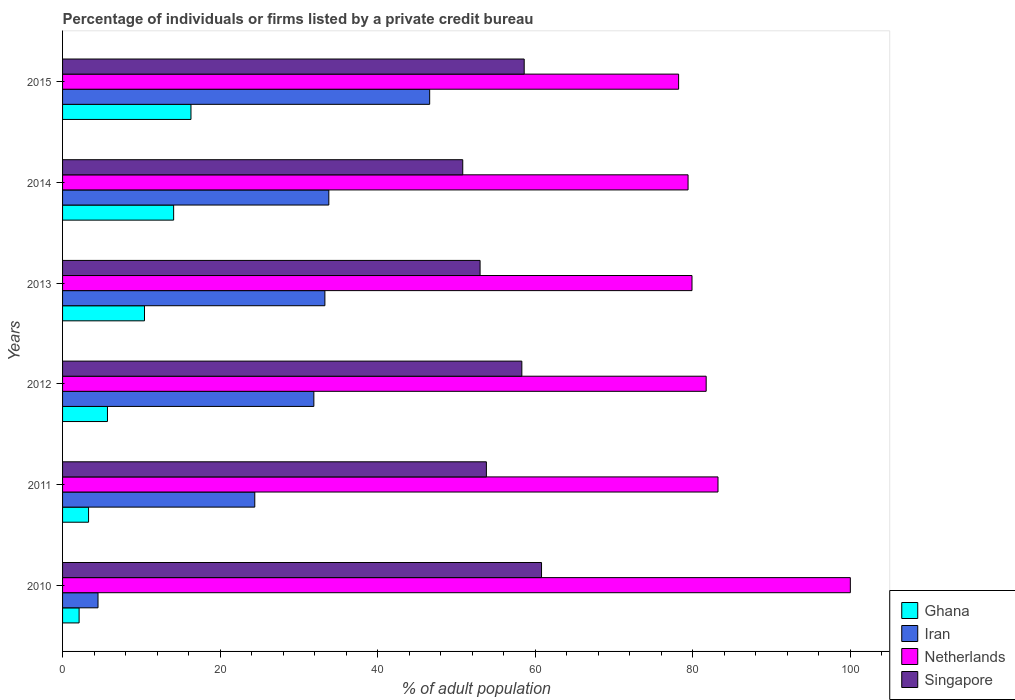How many bars are there on the 6th tick from the top?
Provide a succinct answer. 4. What is the label of the 1st group of bars from the top?
Give a very brief answer. 2015. What is the percentage of population listed by a private credit bureau in Iran in 2015?
Provide a short and direct response. 46.6. Across all years, what is the minimum percentage of population listed by a private credit bureau in Iran?
Make the answer very short. 4.5. In which year was the percentage of population listed by a private credit bureau in Ghana maximum?
Offer a very short reply. 2015. What is the total percentage of population listed by a private credit bureau in Ghana in the graph?
Give a very brief answer. 51.9. What is the difference between the percentage of population listed by a private credit bureau in Ghana in 2010 and that in 2014?
Provide a short and direct response. -12. What is the difference between the percentage of population listed by a private credit bureau in Ghana in 2010 and the percentage of population listed by a private credit bureau in Netherlands in 2011?
Make the answer very short. -81.1. What is the average percentage of population listed by a private credit bureau in Iran per year?
Keep it short and to the point. 29.08. In the year 2011, what is the difference between the percentage of population listed by a private credit bureau in Singapore and percentage of population listed by a private credit bureau in Netherlands?
Your answer should be very brief. -29.4. What is the ratio of the percentage of population listed by a private credit bureau in Singapore in 2010 to that in 2015?
Ensure brevity in your answer.  1.04. Is the percentage of population listed by a private credit bureau in Netherlands in 2014 less than that in 2015?
Offer a terse response. No. Is the difference between the percentage of population listed by a private credit bureau in Singapore in 2011 and 2012 greater than the difference between the percentage of population listed by a private credit bureau in Netherlands in 2011 and 2012?
Keep it short and to the point. No. What is the difference between the highest and the second highest percentage of population listed by a private credit bureau in Netherlands?
Your response must be concise. 16.8. What is the difference between the highest and the lowest percentage of population listed by a private credit bureau in Netherlands?
Offer a very short reply. 21.8. What does the 3rd bar from the top in 2010 represents?
Ensure brevity in your answer.  Iran. What does the 2nd bar from the bottom in 2011 represents?
Keep it short and to the point. Iran. Is it the case that in every year, the sum of the percentage of population listed by a private credit bureau in Netherlands and percentage of population listed by a private credit bureau in Iran is greater than the percentage of population listed by a private credit bureau in Singapore?
Offer a very short reply. Yes. Are all the bars in the graph horizontal?
Make the answer very short. Yes. Are the values on the major ticks of X-axis written in scientific E-notation?
Give a very brief answer. No. Does the graph contain any zero values?
Keep it short and to the point. No. Does the graph contain grids?
Provide a succinct answer. No. Where does the legend appear in the graph?
Make the answer very short. Bottom right. How many legend labels are there?
Ensure brevity in your answer.  4. How are the legend labels stacked?
Make the answer very short. Vertical. What is the title of the graph?
Your answer should be compact. Percentage of individuals or firms listed by a private credit bureau. What is the label or title of the X-axis?
Make the answer very short. % of adult population. What is the label or title of the Y-axis?
Your answer should be compact. Years. What is the % of adult population of Iran in 2010?
Offer a very short reply. 4.5. What is the % of adult population in Singapore in 2010?
Keep it short and to the point. 60.8. What is the % of adult population in Iran in 2011?
Offer a very short reply. 24.4. What is the % of adult population in Netherlands in 2011?
Your response must be concise. 83.2. What is the % of adult population in Singapore in 2011?
Your answer should be compact. 53.8. What is the % of adult population in Ghana in 2012?
Give a very brief answer. 5.7. What is the % of adult population of Iran in 2012?
Provide a short and direct response. 31.9. What is the % of adult population in Netherlands in 2012?
Your answer should be very brief. 81.7. What is the % of adult population in Singapore in 2012?
Offer a very short reply. 58.3. What is the % of adult population of Iran in 2013?
Keep it short and to the point. 33.3. What is the % of adult population in Netherlands in 2013?
Ensure brevity in your answer.  79.9. What is the % of adult population in Singapore in 2013?
Your answer should be very brief. 53. What is the % of adult population of Iran in 2014?
Your answer should be compact. 33.8. What is the % of adult population in Netherlands in 2014?
Give a very brief answer. 79.4. What is the % of adult population in Singapore in 2014?
Your answer should be compact. 50.8. What is the % of adult population in Iran in 2015?
Give a very brief answer. 46.6. What is the % of adult population of Netherlands in 2015?
Your answer should be compact. 78.2. What is the % of adult population of Singapore in 2015?
Your answer should be compact. 58.6. Across all years, what is the maximum % of adult population of Iran?
Keep it short and to the point. 46.6. Across all years, what is the maximum % of adult population in Netherlands?
Keep it short and to the point. 100. Across all years, what is the maximum % of adult population of Singapore?
Provide a short and direct response. 60.8. Across all years, what is the minimum % of adult population in Netherlands?
Make the answer very short. 78.2. Across all years, what is the minimum % of adult population in Singapore?
Give a very brief answer. 50.8. What is the total % of adult population in Ghana in the graph?
Offer a terse response. 51.9. What is the total % of adult population in Iran in the graph?
Ensure brevity in your answer.  174.5. What is the total % of adult population of Netherlands in the graph?
Ensure brevity in your answer.  502.4. What is the total % of adult population of Singapore in the graph?
Ensure brevity in your answer.  335.3. What is the difference between the % of adult population in Ghana in 2010 and that in 2011?
Provide a succinct answer. -1.2. What is the difference between the % of adult population of Iran in 2010 and that in 2011?
Offer a very short reply. -19.9. What is the difference between the % of adult population in Iran in 2010 and that in 2012?
Provide a short and direct response. -27.4. What is the difference between the % of adult population in Singapore in 2010 and that in 2012?
Make the answer very short. 2.5. What is the difference between the % of adult population of Iran in 2010 and that in 2013?
Keep it short and to the point. -28.8. What is the difference between the % of adult population of Netherlands in 2010 and that in 2013?
Keep it short and to the point. 20.1. What is the difference between the % of adult population of Singapore in 2010 and that in 2013?
Offer a very short reply. 7.8. What is the difference between the % of adult population in Iran in 2010 and that in 2014?
Your answer should be compact. -29.3. What is the difference between the % of adult population in Netherlands in 2010 and that in 2014?
Your answer should be compact. 20.6. What is the difference between the % of adult population in Singapore in 2010 and that in 2014?
Your answer should be very brief. 10. What is the difference between the % of adult population in Ghana in 2010 and that in 2015?
Your response must be concise. -14.2. What is the difference between the % of adult population of Iran in 2010 and that in 2015?
Your answer should be compact. -42.1. What is the difference between the % of adult population of Netherlands in 2010 and that in 2015?
Provide a short and direct response. 21.8. What is the difference between the % of adult population in Singapore in 2010 and that in 2015?
Your response must be concise. 2.2. What is the difference between the % of adult population of Ghana in 2011 and that in 2012?
Ensure brevity in your answer.  -2.4. What is the difference between the % of adult population of Netherlands in 2011 and that in 2012?
Keep it short and to the point. 1.5. What is the difference between the % of adult population of Singapore in 2011 and that in 2012?
Keep it short and to the point. -4.5. What is the difference between the % of adult population in Ghana in 2011 and that in 2013?
Your answer should be compact. -7.1. What is the difference between the % of adult population of Iran in 2011 and that in 2013?
Provide a short and direct response. -8.9. What is the difference between the % of adult population in Singapore in 2011 and that in 2013?
Your answer should be very brief. 0.8. What is the difference between the % of adult population of Singapore in 2011 and that in 2014?
Your answer should be very brief. 3. What is the difference between the % of adult population of Ghana in 2011 and that in 2015?
Provide a succinct answer. -13. What is the difference between the % of adult population of Iran in 2011 and that in 2015?
Your response must be concise. -22.2. What is the difference between the % of adult population in Singapore in 2011 and that in 2015?
Offer a very short reply. -4.8. What is the difference between the % of adult population in Iran in 2012 and that in 2013?
Your response must be concise. -1.4. What is the difference between the % of adult population of Iran in 2012 and that in 2014?
Provide a succinct answer. -1.9. What is the difference between the % of adult population of Singapore in 2012 and that in 2014?
Provide a short and direct response. 7.5. What is the difference between the % of adult population in Iran in 2012 and that in 2015?
Provide a succinct answer. -14.7. What is the difference between the % of adult population of Singapore in 2012 and that in 2015?
Ensure brevity in your answer.  -0.3. What is the difference between the % of adult population in Netherlands in 2013 and that in 2014?
Your response must be concise. 0.5. What is the difference between the % of adult population of Netherlands in 2013 and that in 2015?
Offer a terse response. 1.7. What is the difference between the % of adult population of Ghana in 2014 and that in 2015?
Provide a succinct answer. -2.2. What is the difference between the % of adult population of Singapore in 2014 and that in 2015?
Your answer should be very brief. -7.8. What is the difference between the % of adult population of Ghana in 2010 and the % of adult population of Iran in 2011?
Your answer should be compact. -22.3. What is the difference between the % of adult population of Ghana in 2010 and the % of adult population of Netherlands in 2011?
Provide a succinct answer. -81.1. What is the difference between the % of adult population of Ghana in 2010 and the % of adult population of Singapore in 2011?
Provide a short and direct response. -51.7. What is the difference between the % of adult population in Iran in 2010 and the % of adult population in Netherlands in 2011?
Provide a short and direct response. -78.7. What is the difference between the % of adult population of Iran in 2010 and the % of adult population of Singapore in 2011?
Your answer should be compact. -49.3. What is the difference between the % of adult population of Netherlands in 2010 and the % of adult population of Singapore in 2011?
Offer a terse response. 46.2. What is the difference between the % of adult population in Ghana in 2010 and the % of adult population in Iran in 2012?
Your response must be concise. -29.8. What is the difference between the % of adult population in Ghana in 2010 and the % of adult population in Netherlands in 2012?
Your response must be concise. -79.6. What is the difference between the % of adult population in Ghana in 2010 and the % of adult population in Singapore in 2012?
Provide a succinct answer. -56.2. What is the difference between the % of adult population of Iran in 2010 and the % of adult population of Netherlands in 2012?
Provide a succinct answer. -77.2. What is the difference between the % of adult population of Iran in 2010 and the % of adult population of Singapore in 2012?
Provide a succinct answer. -53.8. What is the difference between the % of adult population in Netherlands in 2010 and the % of adult population in Singapore in 2012?
Offer a terse response. 41.7. What is the difference between the % of adult population of Ghana in 2010 and the % of adult population of Iran in 2013?
Your answer should be very brief. -31.2. What is the difference between the % of adult population of Ghana in 2010 and the % of adult population of Netherlands in 2013?
Your answer should be compact. -77.8. What is the difference between the % of adult population in Ghana in 2010 and the % of adult population in Singapore in 2013?
Ensure brevity in your answer.  -50.9. What is the difference between the % of adult population of Iran in 2010 and the % of adult population of Netherlands in 2013?
Ensure brevity in your answer.  -75.4. What is the difference between the % of adult population of Iran in 2010 and the % of adult population of Singapore in 2013?
Provide a succinct answer. -48.5. What is the difference between the % of adult population in Ghana in 2010 and the % of adult population in Iran in 2014?
Your response must be concise. -31.7. What is the difference between the % of adult population in Ghana in 2010 and the % of adult population in Netherlands in 2014?
Your answer should be compact. -77.3. What is the difference between the % of adult population of Ghana in 2010 and the % of adult population of Singapore in 2014?
Ensure brevity in your answer.  -48.7. What is the difference between the % of adult population in Iran in 2010 and the % of adult population in Netherlands in 2014?
Give a very brief answer. -74.9. What is the difference between the % of adult population of Iran in 2010 and the % of adult population of Singapore in 2014?
Your answer should be compact. -46.3. What is the difference between the % of adult population in Netherlands in 2010 and the % of adult population in Singapore in 2014?
Provide a succinct answer. 49.2. What is the difference between the % of adult population in Ghana in 2010 and the % of adult population in Iran in 2015?
Offer a very short reply. -44.5. What is the difference between the % of adult population in Ghana in 2010 and the % of adult population in Netherlands in 2015?
Your response must be concise. -76.1. What is the difference between the % of adult population in Ghana in 2010 and the % of adult population in Singapore in 2015?
Your response must be concise. -56.5. What is the difference between the % of adult population of Iran in 2010 and the % of adult population of Netherlands in 2015?
Give a very brief answer. -73.7. What is the difference between the % of adult population in Iran in 2010 and the % of adult population in Singapore in 2015?
Your answer should be compact. -54.1. What is the difference between the % of adult population of Netherlands in 2010 and the % of adult population of Singapore in 2015?
Provide a succinct answer. 41.4. What is the difference between the % of adult population of Ghana in 2011 and the % of adult population of Iran in 2012?
Ensure brevity in your answer.  -28.6. What is the difference between the % of adult population in Ghana in 2011 and the % of adult population in Netherlands in 2012?
Offer a terse response. -78.4. What is the difference between the % of adult population of Ghana in 2011 and the % of adult population of Singapore in 2012?
Ensure brevity in your answer.  -55. What is the difference between the % of adult population of Iran in 2011 and the % of adult population of Netherlands in 2012?
Provide a succinct answer. -57.3. What is the difference between the % of adult population in Iran in 2011 and the % of adult population in Singapore in 2012?
Your answer should be compact. -33.9. What is the difference between the % of adult population of Netherlands in 2011 and the % of adult population of Singapore in 2012?
Offer a terse response. 24.9. What is the difference between the % of adult population of Ghana in 2011 and the % of adult population of Netherlands in 2013?
Your answer should be very brief. -76.6. What is the difference between the % of adult population in Ghana in 2011 and the % of adult population in Singapore in 2013?
Provide a short and direct response. -49.7. What is the difference between the % of adult population in Iran in 2011 and the % of adult population in Netherlands in 2013?
Offer a terse response. -55.5. What is the difference between the % of adult population in Iran in 2011 and the % of adult population in Singapore in 2013?
Your response must be concise. -28.6. What is the difference between the % of adult population of Netherlands in 2011 and the % of adult population of Singapore in 2013?
Ensure brevity in your answer.  30.2. What is the difference between the % of adult population in Ghana in 2011 and the % of adult population in Iran in 2014?
Offer a very short reply. -30.5. What is the difference between the % of adult population of Ghana in 2011 and the % of adult population of Netherlands in 2014?
Provide a short and direct response. -76.1. What is the difference between the % of adult population of Ghana in 2011 and the % of adult population of Singapore in 2014?
Your response must be concise. -47.5. What is the difference between the % of adult population of Iran in 2011 and the % of adult population of Netherlands in 2014?
Your answer should be compact. -55. What is the difference between the % of adult population in Iran in 2011 and the % of adult population in Singapore in 2014?
Your answer should be very brief. -26.4. What is the difference between the % of adult population in Netherlands in 2011 and the % of adult population in Singapore in 2014?
Give a very brief answer. 32.4. What is the difference between the % of adult population in Ghana in 2011 and the % of adult population in Iran in 2015?
Your response must be concise. -43.3. What is the difference between the % of adult population of Ghana in 2011 and the % of adult population of Netherlands in 2015?
Your answer should be very brief. -74.9. What is the difference between the % of adult population of Ghana in 2011 and the % of adult population of Singapore in 2015?
Ensure brevity in your answer.  -55.3. What is the difference between the % of adult population in Iran in 2011 and the % of adult population in Netherlands in 2015?
Make the answer very short. -53.8. What is the difference between the % of adult population of Iran in 2011 and the % of adult population of Singapore in 2015?
Provide a succinct answer. -34.2. What is the difference between the % of adult population of Netherlands in 2011 and the % of adult population of Singapore in 2015?
Ensure brevity in your answer.  24.6. What is the difference between the % of adult population in Ghana in 2012 and the % of adult population in Iran in 2013?
Your answer should be compact. -27.6. What is the difference between the % of adult population of Ghana in 2012 and the % of adult population of Netherlands in 2013?
Offer a terse response. -74.2. What is the difference between the % of adult population of Ghana in 2012 and the % of adult population of Singapore in 2013?
Provide a short and direct response. -47.3. What is the difference between the % of adult population of Iran in 2012 and the % of adult population of Netherlands in 2013?
Your answer should be very brief. -48. What is the difference between the % of adult population in Iran in 2012 and the % of adult population in Singapore in 2013?
Your answer should be very brief. -21.1. What is the difference between the % of adult population in Netherlands in 2012 and the % of adult population in Singapore in 2013?
Your answer should be compact. 28.7. What is the difference between the % of adult population in Ghana in 2012 and the % of adult population in Iran in 2014?
Your response must be concise. -28.1. What is the difference between the % of adult population in Ghana in 2012 and the % of adult population in Netherlands in 2014?
Offer a terse response. -73.7. What is the difference between the % of adult population of Ghana in 2012 and the % of adult population of Singapore in 2014?
Provide a succinct answer. -45.1. What is the difference between the % of adult population of Iran in 2012 and the % of adult population of Netherlands in 2014?
Ensure brevity in your answer.  -47.5. What is the difference between the % of adult population of Iran in 2012 and the % of adult population of Singapore in 2014?
Your response must be concise. -18.9. What is the difference between the % of adult population of Netherlands in 2012 and the % of adult population of Singapore in 2014?
Make the answer very short. 30.9. What is the difference between the % of adult population of Ghana in 2012 and the % of adult population of Iran in 2015?
Your answer should be very brief. -40.9. What is the difference between the % of adult population in Ghana in 2012 and the % of adult population in Netherlands in 2015?
Offer a terse response. -72.5. What is the difference between the % of adult population of Ghana in 2012 and the % of adult population of Singapore in 2015?
Provide a short and direct response. -52.9. What is the difference between the % of adult population of Iran in 2012 and the % of adult population of Netherlands in 2015?
Give a very brief answer. -46.3. What is the difference between the % of adult population in Iran in 2012 and the % of adult population in Singapore in 2015?
Provide a short and direct response. -26.7. What is the difference between the % of adult population of Netherlands in 2012 and the % of adult population of Singapore in 2015?
Offer a very short reply. 23.1. What is the difference between the % of adult population of Ghana in 2013 and the % of adult population of Iran in 2014?
Make the answer very short. -23.4. What is the difference between the % of adult population in Ghana in 2013 and the % of adult population in Netherlands in 2014?
Offer a very short reply. -69. What is the difference between the % of adult population of Ghana in 2013 and the % of adult population of Singapore in 2014?
Keep it short and to the point. -40.4. What is the difference between the % of adult population of Iran in 2013 and the % of adult population of Netherlands in 2014?
Make the answer very short. -46.1. What is the difference between the % of adult population of Iran in 2013 and the % of adult population of Singapore in 2014?
Make the answer very short. -17.5. What is the difference between the % of adult population in Netherlands in 2013 and the % of adult population in Singapore in 2014?
Provide a short and direct response. 29.1. What is the difference between the % of adult population in Ghana in 2013 and the % of adult population in Iran in 2015?
Offer a terse response. -36.2. What is the difference between the % of adult population of Ghana in 2013 and the % of adult population of Netherlands in 2015?
Ensure brevity in your answer.  -67.8. What is the difference between the % of adult population in Ghana in 2013 and the % of adult population in Singapore in 2015?
Your answer should be compact. -48.2. What is the difference between the % of adult population in Iran in 2013 and the % of adult population in Netherlands in 2015?
Offer a terse response. -44.9. What is the difference between the % of adult population of Iran in 2013 and the % of adult population of Singapore in 2015?
Offer a terse response. -25.3. What is the difference between the % of adult population in Netherlands in 2013 and the % of adult population in Singapore in 2015?
Your answer should be very brief. 21.3. What is the difference between the % of adult population in Ghana in 2014 and the % of adult population in Iran in 2015?
Offer a terse response. -32.5. What is the difference between the % of adult population of Ghana in 2014 and the % of adult population of Netherlands in 2015?
Provide a short and direct response. -64.1. What is the difference between the % of adult population in Ghana in 2014 and the % of adult population in Singapore in 2015?
Offer a very short reply. -44.5. What is the difference between the % of adult population of Iran in 2014 and the % of adult population of Netherlands in 2015?
Give a very brief answer. -44.4. What is the difference between the % of adult population in Iran in 2014 and the % of adult population in Singapore in 2015?
Your response must be concise. -24.8. What is the difference between the % of adult population in Netherlands in 2014 and the % of adult population in Singapore in 2015?
Your answer should be compact. 20.8. What is the average % of adult population in Ghana per year?
Your response must be concise. 8.65. What is the average % of adult population of Iran per year?
Your answer should be very brief. 29.08. What is the average % of adult population in Netherlands per year?
Your response must be concise. 83.73. What is the average % of adult population in Singapore per year?
Offer a terse response. 55.88. In the year 2010, what is the difference between the % of adult population in Ghana and % of adult population in Netherlands?
Your answer should be very brief. -97.9. In the year 2010, what is the difference between the % of adult population of Ghana and % of adult population of Singapore?
Make the answer very short. -58.7. In the year 2010, what is the difference between the % of adult population in Iran and % of adult population in Netherlands?
Offer a very short reply. -95.5. In the year 2010, what is the difference between the % of adult population in Iran and % of adult population in Singapore?
Ensure brevity in your answer.  -56.3. In the year 2010, what is the difference between the % of adult population in Netherlands and % of adult population in Singapore?
Give a very brief answer. 39.2. In the year 2011, what is the difference between the % of adult population of Ghana and % of adult population of Iran?
Offer a very short reply. -21.1. In the year 2011, what is the difference between the % of adult population in Ghana and % of adult population in Netherlands?
Offer a terse response. -79.9. In the year 2011, what is the difference between the % of adult population in Ghana and % of adult population in Singapore?
Provide a short and direct response. -50.5. In the year 2011, what is the difference between the % of adult population of Iran and % of adult population of Netherlands?
Provide a succinct answer. -58.8. In the year 2011, what is the difference between the % of adult population in Iran and % of adult population in Singapore?
Your response must be concise. -29.4. In the year 2011, what is the difference between the % of adult population in Netherlands and % of adult population in Singapore?
Your answer should be compact. 29.4. In the year 2012, what is the difference between the % of adult population in Ghana and % of adult population in Iran?
Offer a terse response. -26.2. In the year 2012, what is the difference between the % of adult population in Ghana and % of adult population in Netherlands?
Keep it short and to the point. -76. In the year 2012, what is the difference between the % of adult population in Ghana and % of adult population in Singapore?
Your response must be concise. -52.6. In the year 2012, what is the difference between the % of adult population in Iran and % of adult population in Netherlands?
Offer a very short reply. -49.8. In the year 2012, what is the difference between the % of adult population of Iran and % of adult population of Singapore?
Offer a terse response. -26.4. In the year 2012, what is the difference between the % of adult population of Netherlands and % of adult population of Singapore?
Your answer should be compact. 23.4. In the year 2013, what is the difference between the % of adult population of Ghana and % of adult population of Iran?
Your response must be concise. -22.9. In the year 2013, what is the difference between the % of adult population of Ghana and % of adult population of Netherlands?
Offer a very short reply. -69.5. In the year 2013, what is the difference between the % of adult population in Ghana and % of adult population in Singapore?
Provide a short and direct response. -42.6. In the year 2013, what is the difference between the % of adult population of Iran and % of adult population of Netherlands?
Your response must be concise. -46.6. In the year 2013, what is the difference between the % of adult population in Iran and % of adult population in Singapore?
Your response must be concise. -19.7. In the year 2013, what is the difference between the % of adult population in Netherlands and % of adult population in Singapore?
Make the answer very short. 26.9. In the year 2014, what is the difference between the % of adult population in Ghana and % of adult population in Iran?
Keep it short and to the point. -19.7. In the year 2014, what is the difference between the % of adult population of Ghana and % of adult population of Netherlands?
Give a very brief answer. -65.3. In the year 2014, what is the difference between the % of adult population of Ghana and % of adult population of Singapore?
Keep it short and to the point. -36.7. In the year 2014, what is the difference between the % of adult population of Iran and % of adult population of Netherlands?
Provide a succinct answer. -45.6. In the year 2014, what is the difference between the % of adult population in Iran and % of adult population in Singapore?
Offer a very short reply. -17. In the year 2014, what is the difference between the % of adult population in Netherlands and % of adult population in Singapore?
Provide a succinct answer. 28.6. In the year 2015, what is the difference between the % of adult population of Ghana and % of adult population of Iran?
Your answer should be compact. -30.3. In the year 2015, what is the difference between the % of adult population in Ghana and % of adult population in Netherlands?
Give a very brief answer. -61.9. In the year 2015, what is the difference between the % of adult population in Ghana and % of adult population in Singapore?
Ensure brevity in your answer.  -42.3. In the year 2015, what is the difference between the % of adult population of Iran and % of adult population of Netherlands?
Keep it short and to the point. -31.6. In the year 2015, what is the difference between the % of adult population of Netherlands and % of adult population of Singapore?
Your answer should be very brief. 19.6. What is the ratio of the % of adult population of Ghana in 2010 to that in 2011?
Provide a short and direct response. 0.64. What is the ratio of the % of adult population in Iran in 2010 to that in 2011?
Provide a short and direct response. 0.18. What is the ratio of the % of adult population of Netherlands in 2010 to that in 2011?
Offer a very short reply. 1.2. What is the ratio of the % of adult population of Singapore in 2010 to that in 2011?
Provide a succinct answer. 1.13. What is the ratio of the % of adult population of Ghana in 2010 to that in 2012?
Your answer should be very brief. 0.37. What is the ratio of the % of adult population in Iran in 2010 to that in 2012?
Ensure brevity in your answer.  0.14. What is the ratio of the % of adult population of Netherlands in 2010 to that in 2012?
Ensure brevity in your answer.  1.22. What is the ratio of the % of adult population of Singapore in 2010 to that in 2012?
Make the answer very short. 1.04. What is the ratio of the % of adult population of Ghana in 2010 to that in 2013?
Provide a short and direct response. 0.2. What is the ratio of the % of adult population in Iran in 2010 to that in 2013?
Give a very brief answer. 0.14. What is the ratio of the % of adult population of Netherlands in 2010 to that in 2013?
Keep it short and to the point. 1.25. What is the ratio of the % of adult population in Singapore in 2010 to that in 2013?
Give a very brief answer. 1.15. What is the ratio of the % of adult population of Ghana in 2010 to that in 2014?
Keep it short and to the point. 0.15. What is the ratio of the % of adult population in Iran in 2010 to that in 2014?
Give a very brief answer. 0.13. What is the ratio of the % of adult population in Netherlands in 2010 to that in 2014?
Your answer should be compact. 1.26. What is the ratio of the % of adult population of Singapore in 2010 to that in 2014?
Your response must be concise. 1.2. What is the ratio of the % of adult population in Ghana in 2010 to that in 2015?
Give a very brief answer. 0.13. What is the ratio of the % of adult population of Iran in 2010 to that in 2015?
Ensure brevity in your answer.  0.1. What is the ratio of the % of adult population of Netherlands in 2010 to that in 2015?
Your response must be concise. 1.28. What is the ratio of the % of adult population in Singapore in 2010 to that in 2015?
Your answer should be compact. 1.04. What is the ratio of the % of adult population of Ghana in 2011 to that in 2012?
Ensure brevity in your answer.  0.58. What is the ratio of the % of adult population of Iran in 2011 to that in 2012?
Provide a succinct answer. 0.76. What is the ratio of the % of adult population of Netherlands in 2011 to that in 2012?
Offer a terse response. 1.02. What is the ratio of the % of adult population in Singapore in 2011 to that in 2012?
Your response must be concise. 0.92. What is the ratio of the % of adult population of Ghana in 2011 to that in 2013?
Your answer should be compact. 0.32. What is the ratio of the % of adult population in Iran in 2011 to that in 2013?
Ensure brevity in your answer.  0.73. What is the ratio of the % of adult population in Netherlands in 2011 to that in 2013?
Offer a very short reply. 1.04. What is the ratio of the % of adult population in Singapore in 2011 to that in 2013?
Offer a terse response. 1.02. What is the ratio of the % of adult population of Ghana in 2011 to that in 2014?
Ensure brevity in your answer.  0.23. What is the ratio of the % of adult population of Iran in 2011 to that in 2014?
Your response must be concise. 0.72. What is the ratio of the % of adult population of Netherlands in 2011 to that in 2014?
Make the answer very short. 1.05. What is the ratio of the % of adult population in Singapore in 2011 to that in 2014?
Provide a succinct answer. 1.06. What is the ratio of the % of adult population in Ghana in 2011 to that in 2015?
Your response must be concise. 0.2. What is the ratio of the % of adult population in Iran in 2011 to that in 2015?
Offer a very short reply. 0.52. What is the ratio of the % of adult population of Netherlands in 2011 to that in 2015?
Provide a succinct answer. 1.06. What is the ratio of the % of adult population of Singapore in 2011 to that in 2015?
Your response must be concise. 0.92. What is the ratio of the % of adult population of Ghana in 2012 to that in 2013?
Keep it short and to the point. 0.55. What is the ratio of the % of adult population of Iran in 2012 to that in 2013?
Your response must be concise. 0.96. What is the ratio of the % of adult population of Netherlands in 2012 to that in 2013?
Offer a very short reply. 1.02. What is the ratio of the % of adult population in Singapore in 2012 to that in 2013?
Offer a terse response. 1.1. What is the ratio of the % of adult population in Ghana in 2012 to that in 2014?
Give a very brief answer. 0.4. What is the ratio of the % of adult population of Iran in 2012 to that in 2014?
Your response must be concise. 0.94. What is the ratio of the % of adult population of Singapore in 2012 to that in 2014?
Ensure brevity in your answer.  1.15. What is the ratio of the % of adult population in Ghana in 2012 to that in 2015?
Keep it short and to the point. 0.35. What is the ratio of the % of adult population of Iran in 2012 to that in 2015?
Provide a succinct answer. 0.68. What is the ratio of the % of adult population of Netherlands in 2012 to that in 2015?
Make the answer very short. 1.04. What is the ratio of the % of adult population of Ghana in 2013 to that in 2014?
Your answer should be very brief. 0.74. What is the ratio of the % of adult population in Iran in 2013 to that in 2014?
Offer a terse response. 0.99. What is the ratio of the % of adult population in Singapore in 2013 to that in 2014?
Provide a succinct answer. 1.04. What is the ratio of the % of adult population of Ghana in 2013 to that in 2015?
Provide a succinct answer. 0.64. What is the ratio of the % of adult population in Iran in 2013 to that in 2015?
Your answer should be compact. 0.71. What is the ratio of the % of adult population in Netherlands in 2013 to that in 2015?
Provide a succinct answer. 1.02. What is the ratio of the % of adult population in Singapore in 2013 to that in 2015?
Offer a terse response. 0.9. What is the ratio of the % of adult population in Ghana in 2014 to that in 2015?
Give a very brief answer. 0.86. What is the ratio of the % of adult population in Iran in 2014 to that in 2015?
Your answer should be compact. 0.73. What is the ratio of the % of adult population in Netherlands in 2014 to that in 2015?
Keep it short and to the point. 1.02. What is the ratio of the % of adult population of Singapore in 2014 to that in 2015?
Ensure brevity in your answer.  0.87. What is the difference between the highest and the second highest % of adult population of Iran?
Make the answer very short. 12.8. What is the difference between the highest and the lowest % of adult population in Iran?
Keep it short and to the point. 42.1. What is the difference between the highest and the lowest % of adult population in Netherlands?
Your response must be concise. 21.8. What is the difference between the highest and the lowest % of adult population of Singapore?
Offer a terse response. 10. 